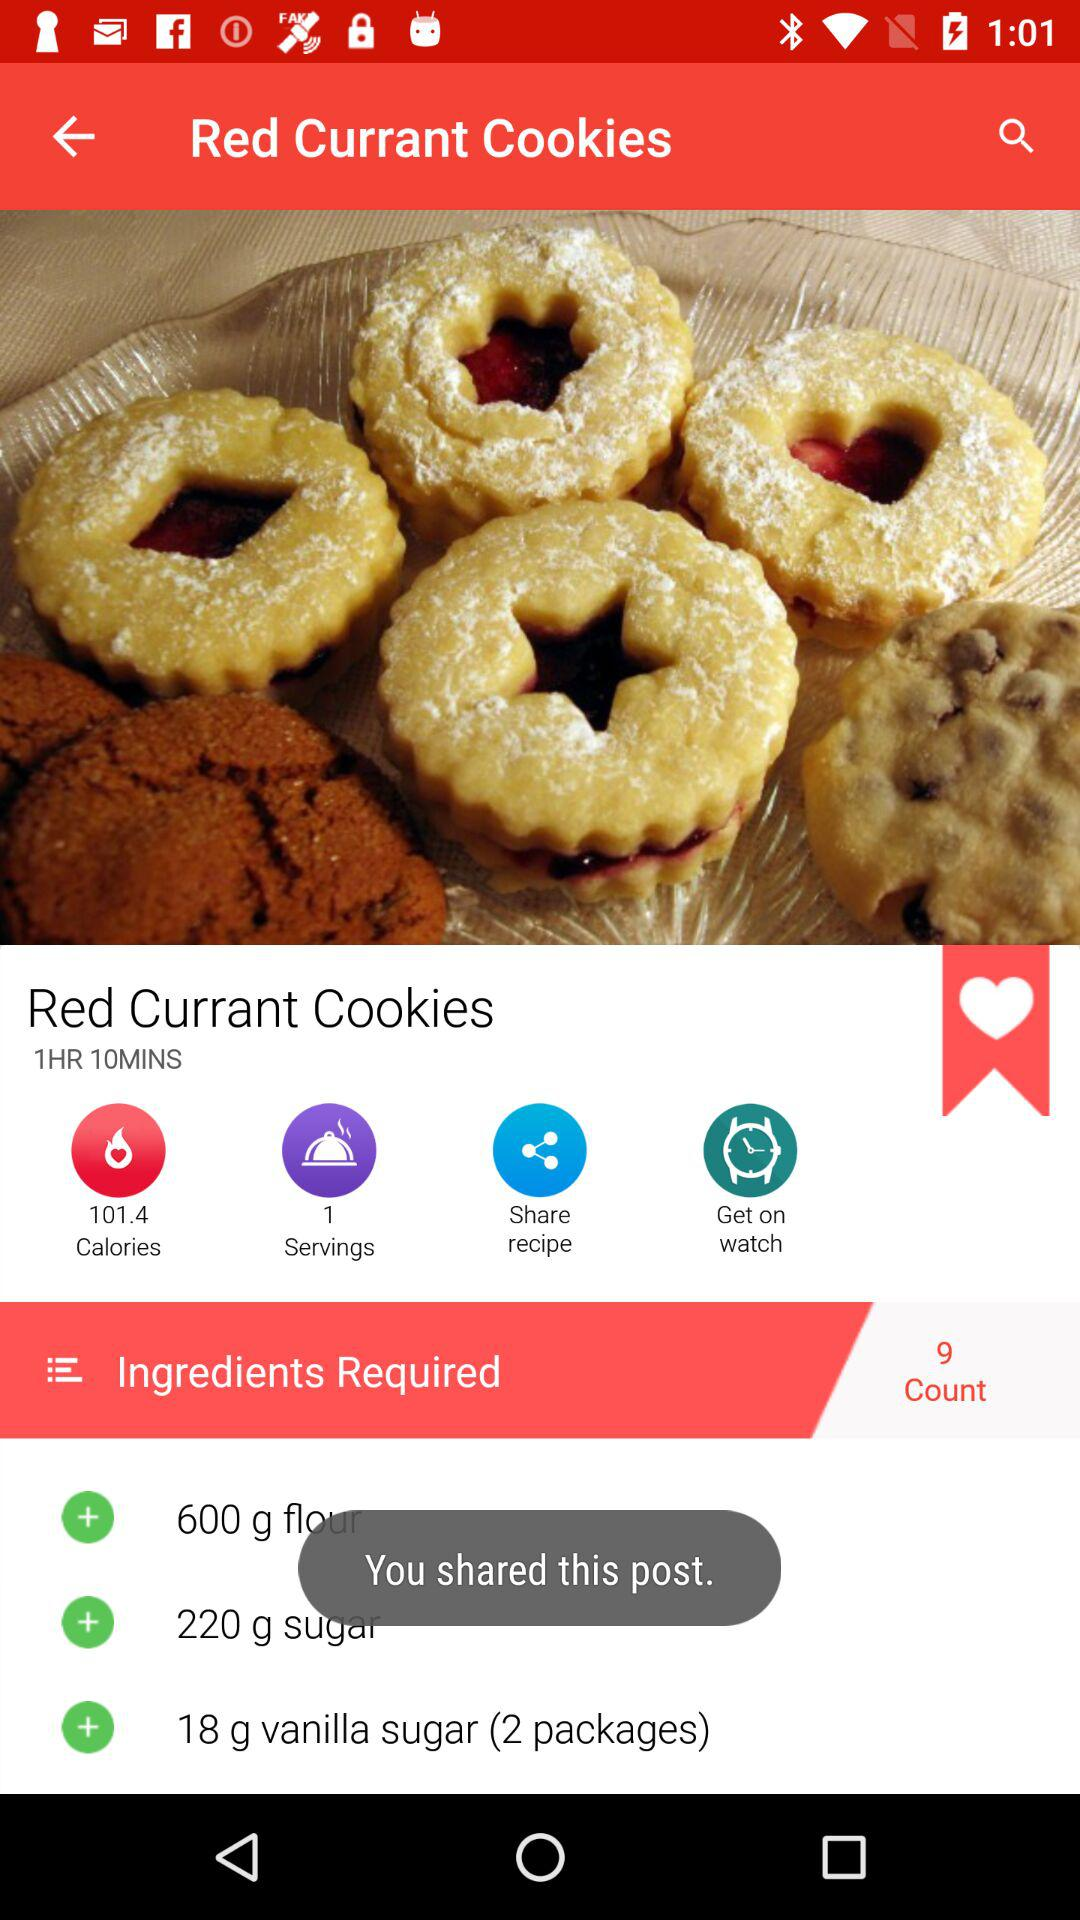How many ingredients are required for "Red Current Cookies"? There are 9 ingredients required for "Red Current Cookies". 